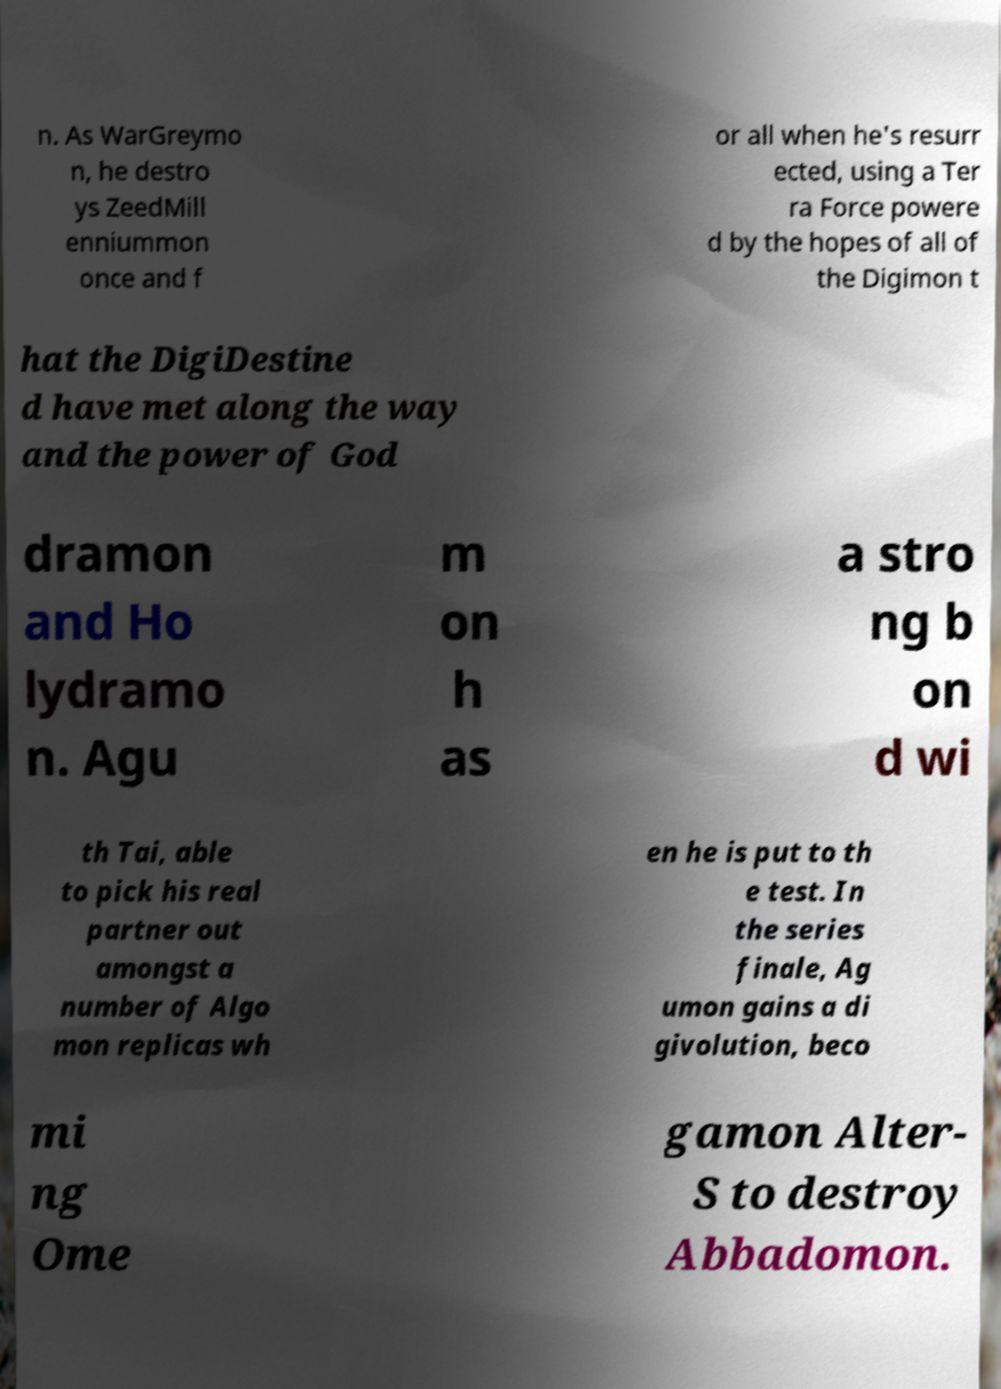What messages or text are displayed in this image? I need them in a readable, typed format. n. As WarGreymo n, he destro ys ZeedMill enniummon once and f or all when he's resurr ected, using a Ter ra Force powere d by the hopes of all of the Digimon t hat the DigiDestine d have met along the way and the power of God dramon and Ho lydramo n. Agu m on h as a stro ng b on d wi th Tai, able to pick his real partner out amongst a number of Algo mon replicas wh en he is put to th e test. In the series finale, Ag umon gains a di givolution, beco mi ng Ome gamon Alter- S to destroy Abbadomon. 